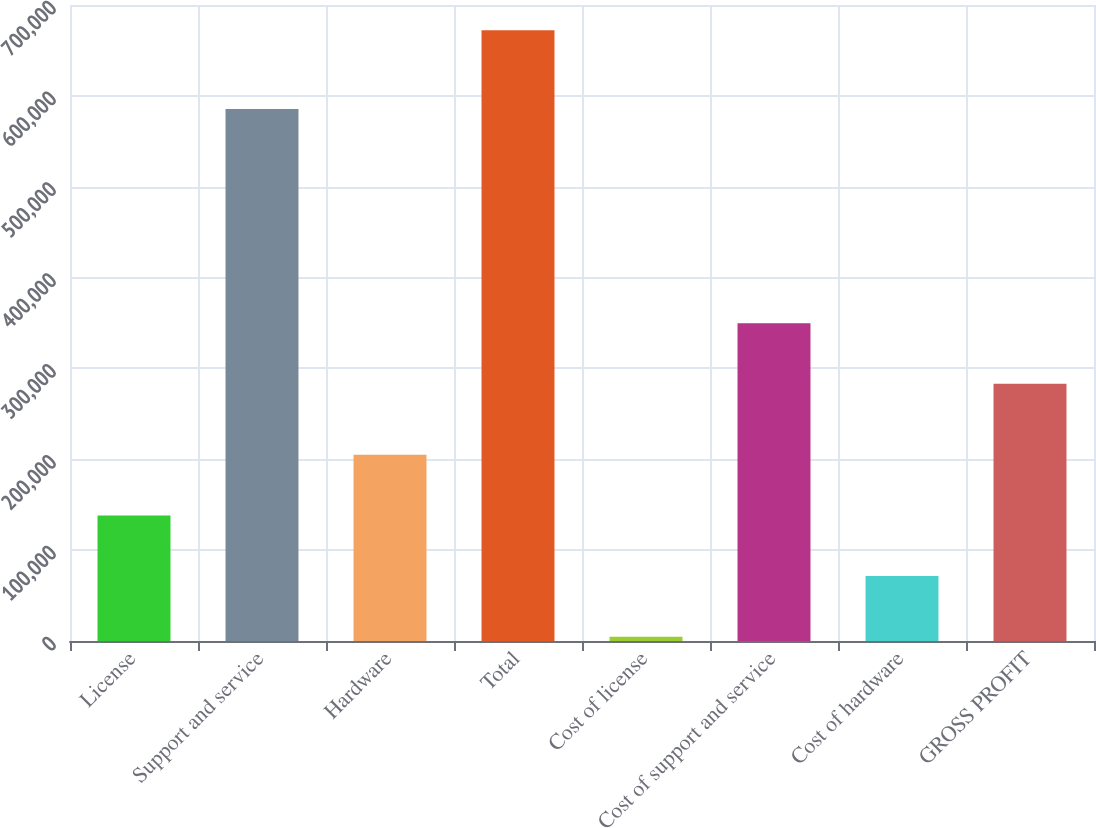Convert chart to OTSL. <chart><loc_0><loc_0><loc_500><loc_500><bar_chart><fcel>License<fcel>Support and service<fcel>Hardware<fcel>Total<fcel>Cost of license<fcel>Cost of support and service<fcel>Cost of hardware<fcel>GROSS PROFIT<nl><fcel>138242<fcel>585470<fcel>204997<fcel>672282<fcel>4732<fcel>349855<fcel>71487<fcel>283100<nl></chart> 